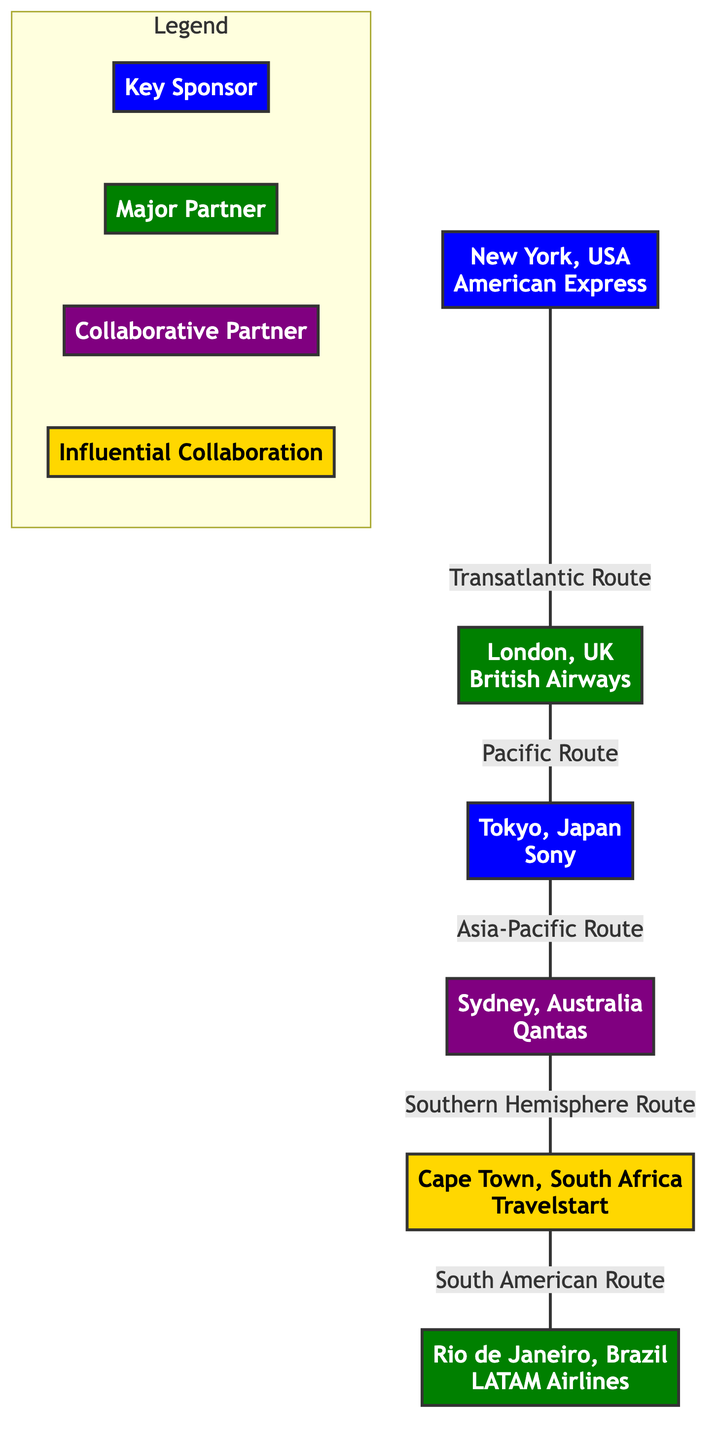What is the key sponsor located in New York? The diagram indicates that American Express is the key sponsor in New York.
Answer: American Express How many major partners are shown in the diagram? By reviewing the nodes classified as major partners, there are two: British Airways and LATAM Airlines.
Answer: 2 What city is associated with the collaborative partner? The only city labeled as a collaborative partner is Sydney, Australia.
Answer: Sydney Which route connects New York to London? The diagram specifies that the route connecting New York and London is labeled as "Transatlantic Route."
Answer: Transatlantic Route What color represents influential collaborations in the diagram? Influential collaborations in the diagram are marked with gold, as indicated by the color fill code.
Answer: Gold Which key sponsor is located in Tokyo? The diagram shows that Sony is the key sponsor located in Tokyo, Japan.
Answer: Sony Which partner is linked with the Southern Hemisphere Route? The Southern Hemisphere Route connects Sydney to Cape Town, showcasing the partnership through this route.
Answer: Sydney What is the total number of nodes in the diagram? Counting all unique locations and their corresponding sponsors or partners, the total is 6 nodes displayed in the diagram.
Answer: 6 Which two cities are directly connected by the Asia-Pacific Route? The Asia-Pacific Route connects Tokyo to Sydney, as illustrated in the diagram.
Answer: Tokyo and Sydney What type of partnership is represented in Cape Town? The partnership represented in Cape Town is classified as an influential collaboration according to the diagram's legend.
Answer: Influential Collaboration 